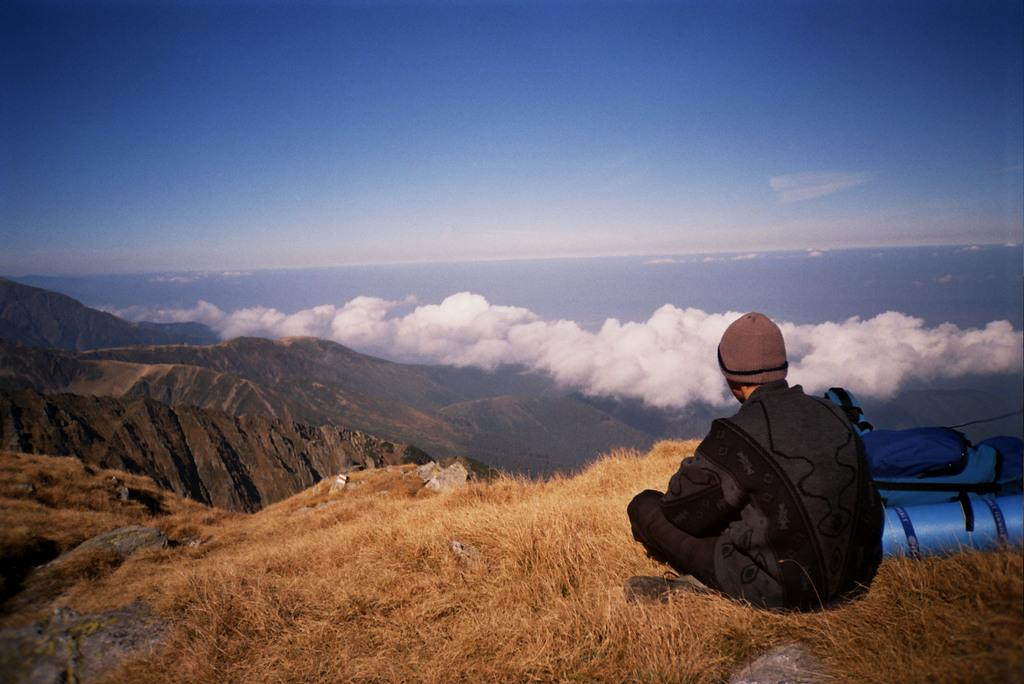Who is in the picture? There is a man in the picture. What is the man wearing on his head? The man is wearing a cap. Where is the man sitting? The man is sitting on dry grass. What is the location of the man? The man is on a mountain. What is the man looking at? The man is looking at mountains. How would you describe the sky in the picture? The sky is blue with white clouds. What is the man's mom doing in the picture? There is no mention of the man's mom in the image or the provided facts. Can you see any ghosts in the picture? There are no ghosts present in the image. 